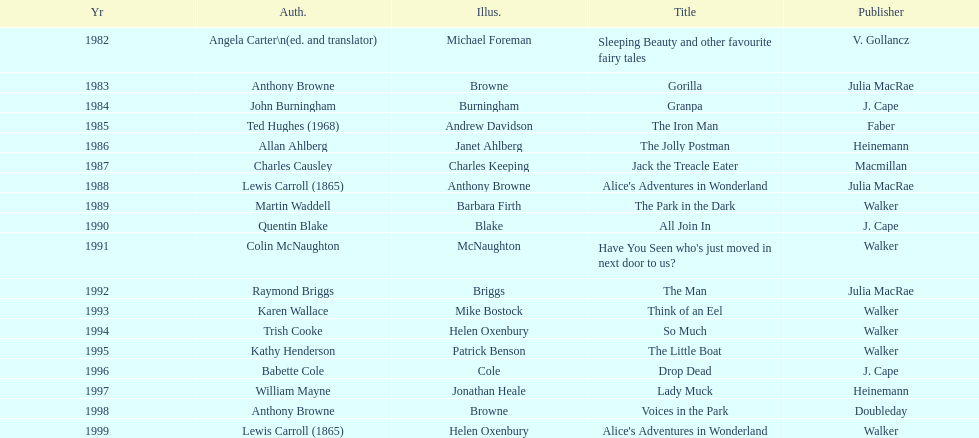How many times has anthony browne won an kurt maschler award for illustration? 3. 